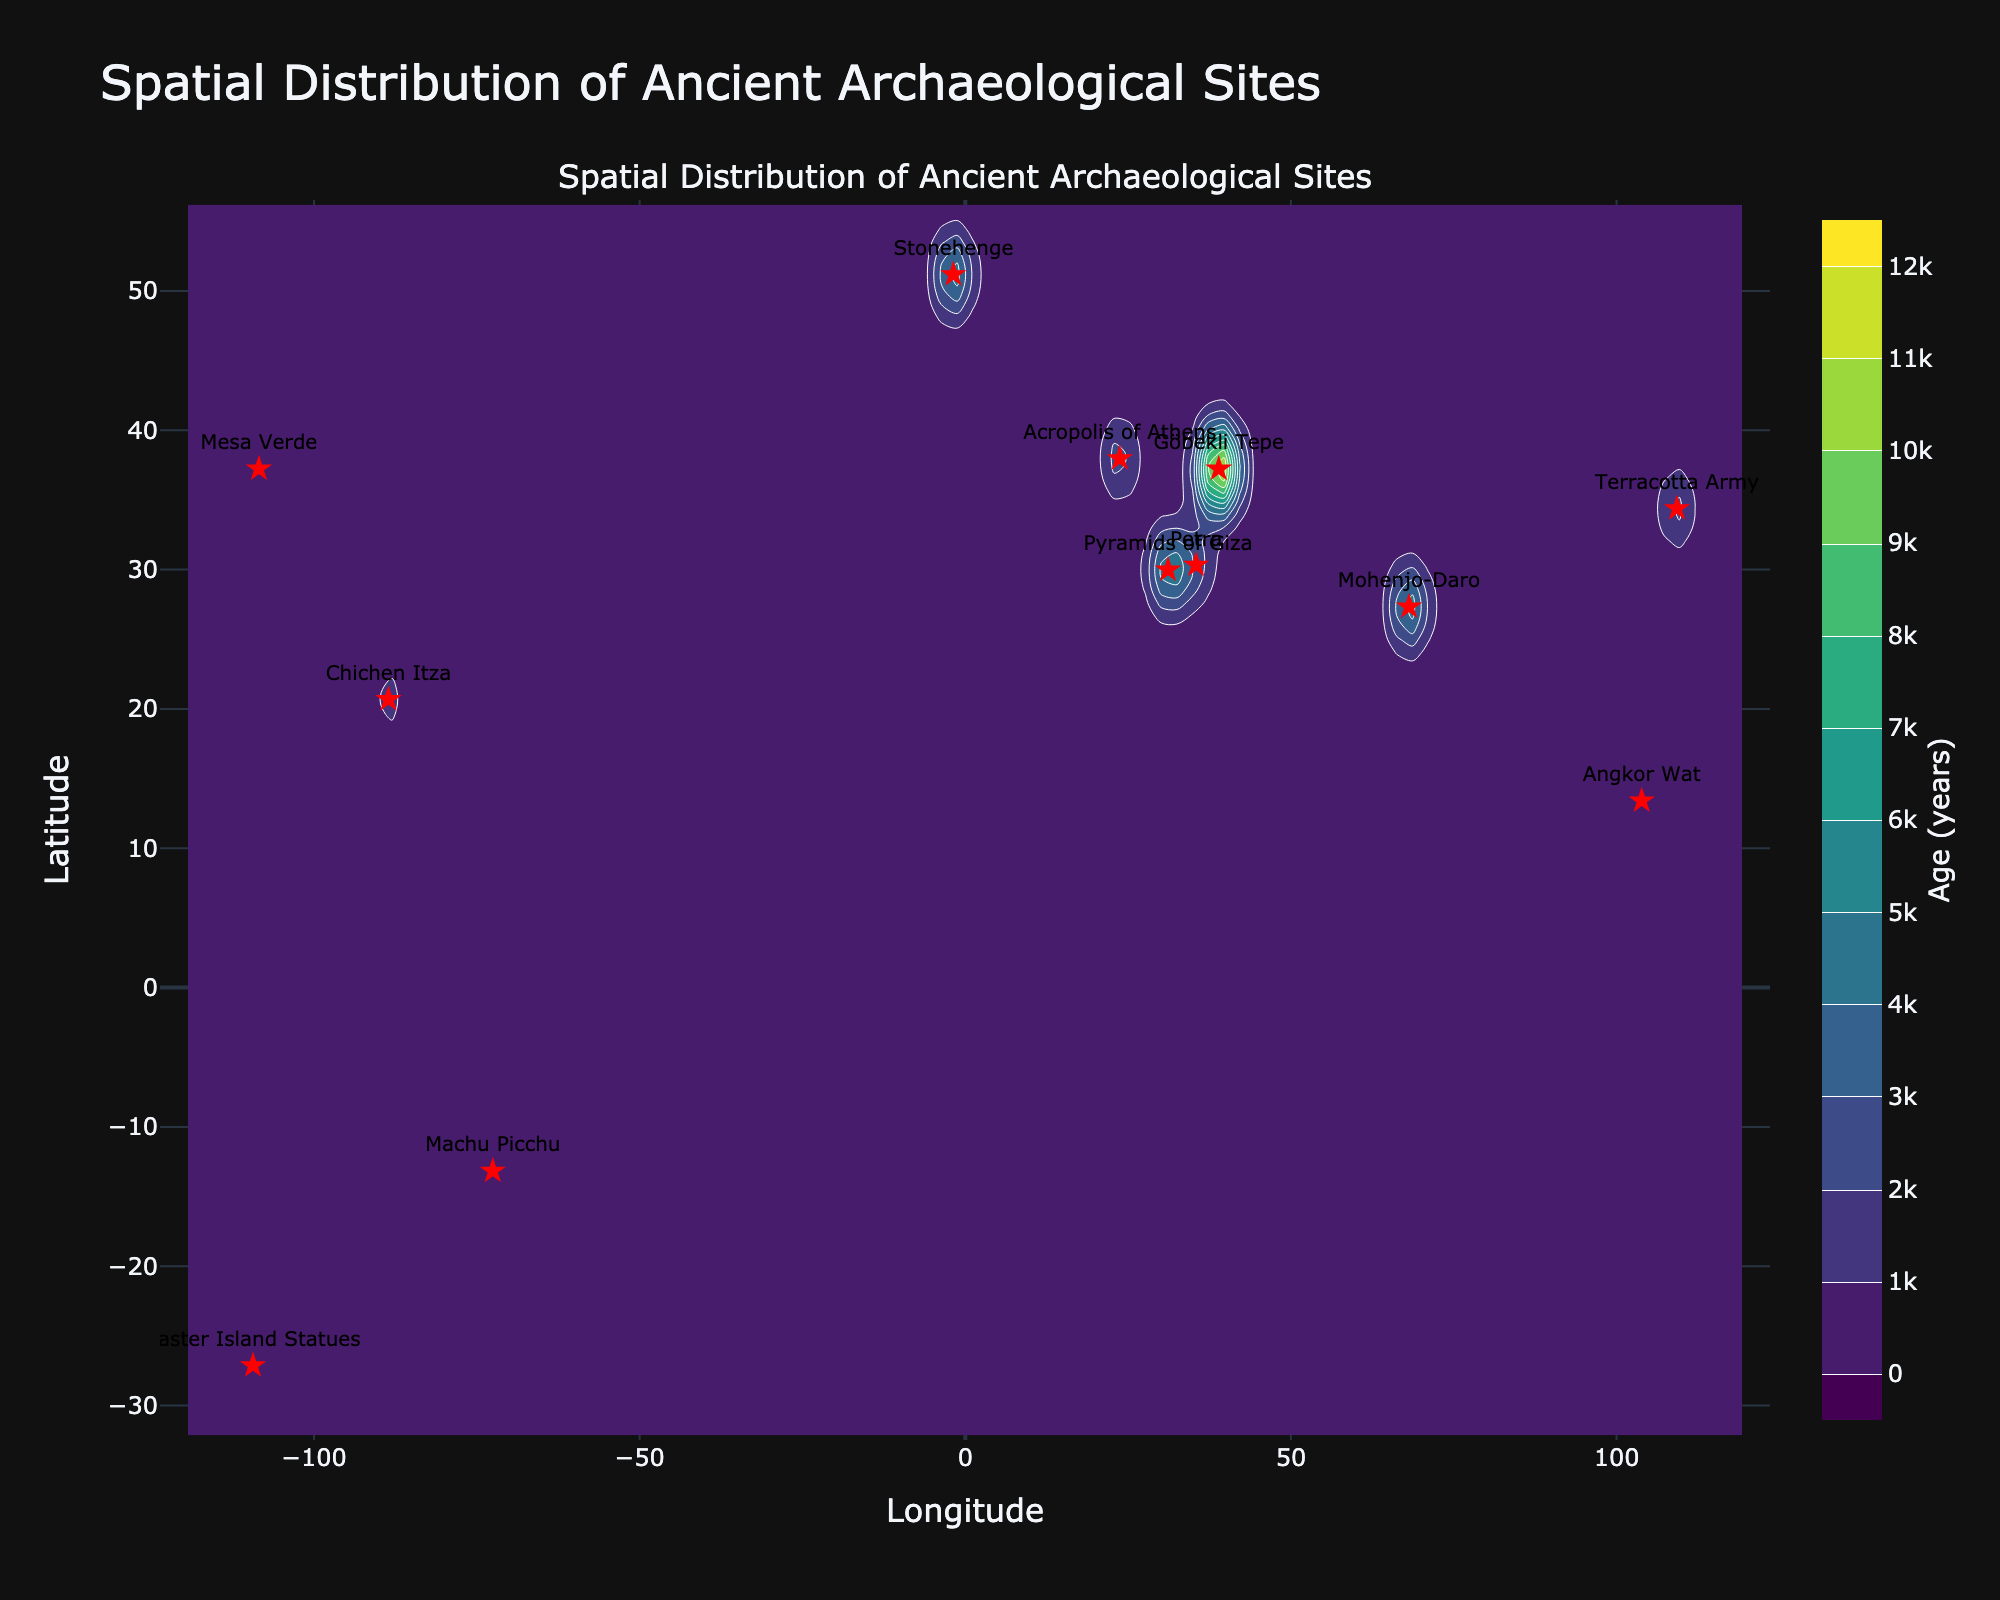what is the title of the plot? The title of the plot is displayed prominently at the top of the figure. It summarizes what the plot represents.
Answer: Spatial Distribution of Ancient Archaeological Sites What is the highest age interval shown on the contour colorbar? The contour colorbar on the right side of the figure shows age intervals, with the highest interval labeled at the top.
Answer: 12000 years Which site is located farthest south? By looking at the latitudinal coordinates of the sites represented by red stars, the one with the lowest latitude value is the farthest south.
Answer: Easter Island Statues Which site is located closest to the equator? The site with the latitude closest to 0 degrees is the one nearest to the equator.
Answer: Machu Picchu Which sites have approximately the same age? Sites that have similar age labels next to the red stars are considered to have approximately the same age.
Answer: Stonehenge, Pyramids of Giza, and Mohenjo-Daro What is the range of longitudes shown in the plot? The x-axis of the plot shows longitudes. The range can be determined by looking at the minimum and maximum values along this axis.
Answer: -120 to 120 degrees How does the age of Mesa Verde compare to that of Chichen Itza? Locate the red stars labeled "Mesa Verde" and "Chichen Itza" on the plot, then compare their age labels directly.
Answer: Mesa Verde is younger In which area do the ages of the archaeological sites vary the most? Examine the contour lines and color gradients on the plot. The region with the most varying contour lines and color changes indicates the greatest variation in ages.
Answer: The region near Göbekli Tepe Why might the site at Göbekli Tepe have a significant impact on the age interpolation on the contour plot? Göbekli Tepe's age is notably higher than the other sites, influencing the interpolation and creating a broader spread of age values in its vicinity.
Answer: It is the oldest site on the plot 